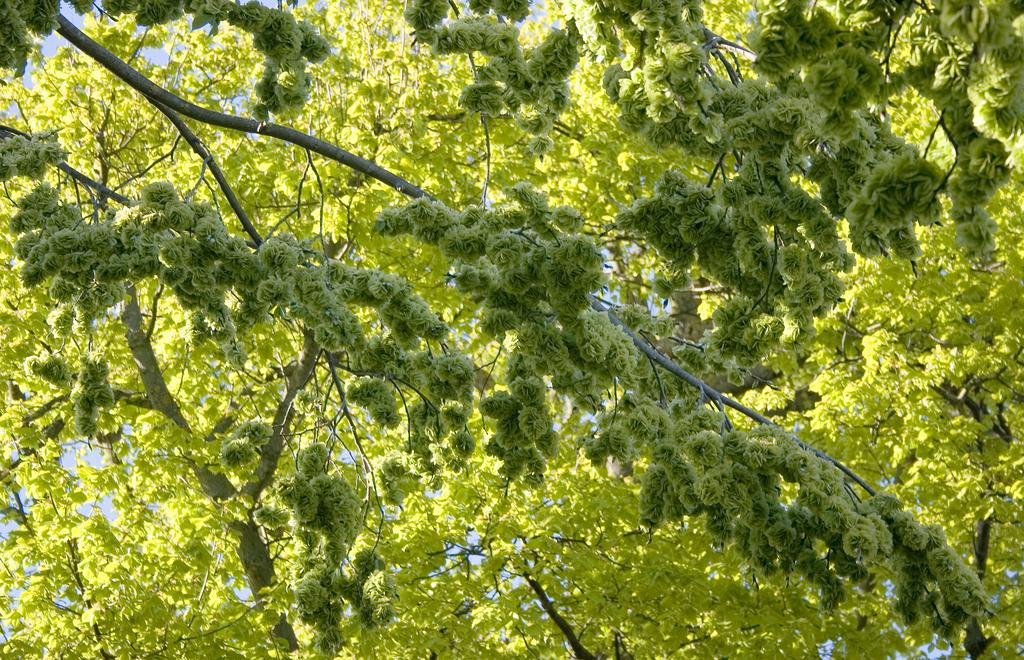What type of vegetation can be seen in the image? There are trees in the image. What part of the natural environment is visible in the image? The sky is visible in the image. How many cherries are hanging from the trees in the image? There are no cherries present in the image; it only features trees and the sky. 